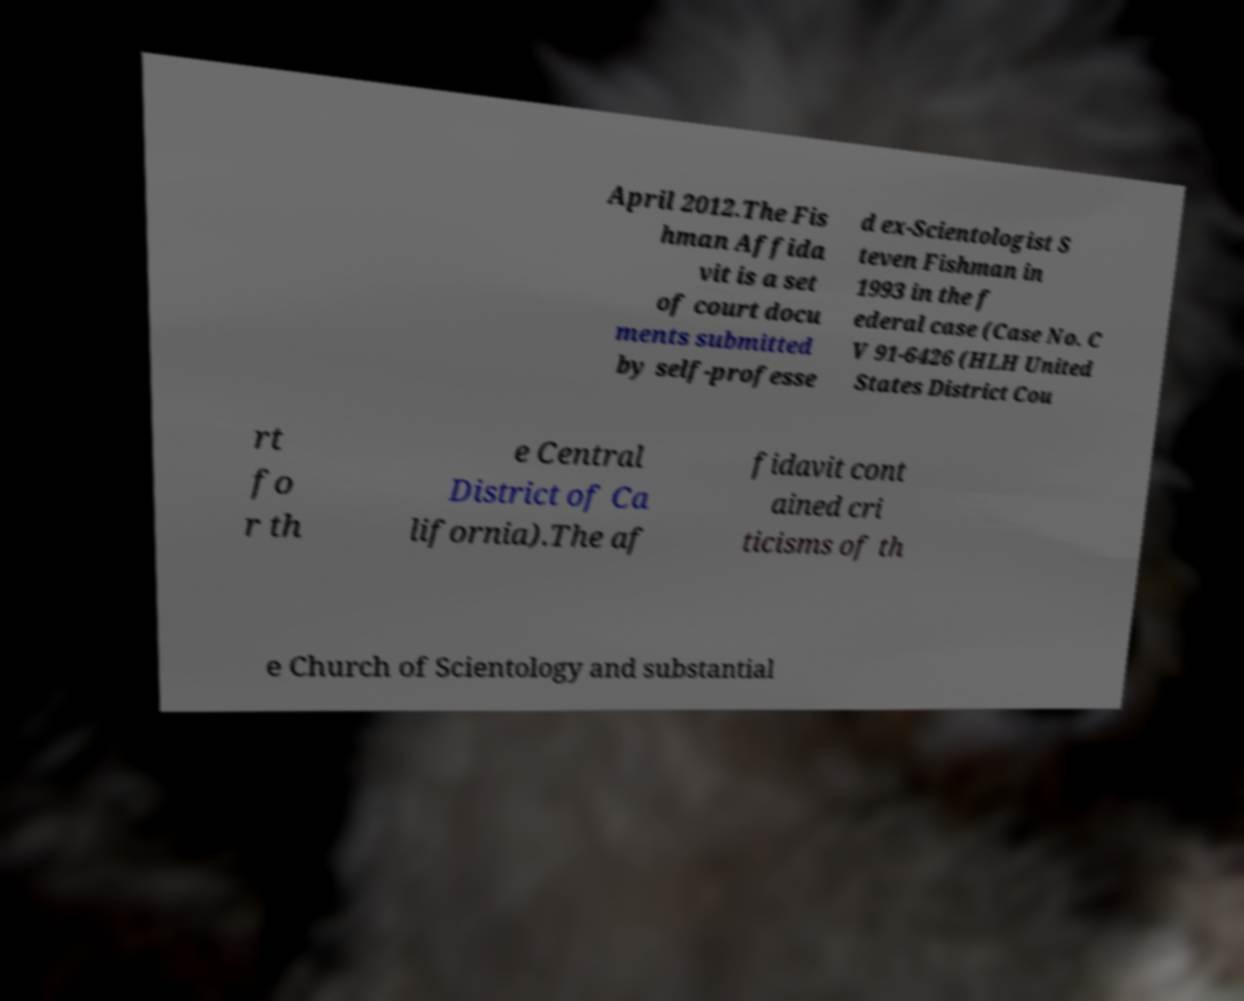Could you assist in decoding the text presented in this image and type it out clearly? April 2012.The Fis hman Affida vit is a set of court docu ments submitted by self-professe d ex-Scientologist S teven Fishman in 1993 in the f ederal case (Case No. C V 91-6426 (HLH United States District Cou rt fo r th e Central District of Ca lifornia).The af fidavit cont ained cri ticisms of th e Church of Scientology and substantial 